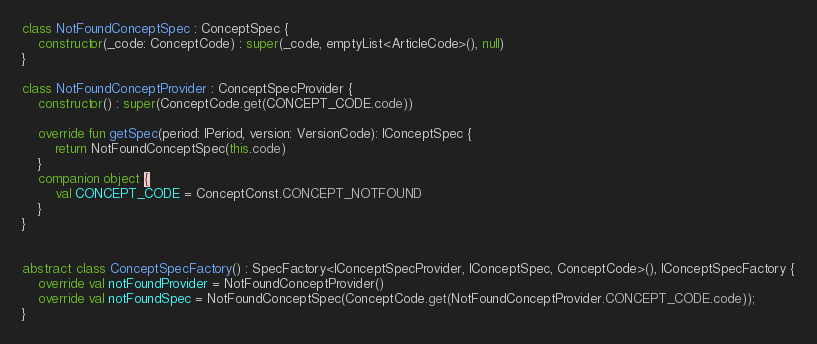<code> <loc_0><loc_0><loc_500><loc_500><_Kotlin_>class NotFoundConceptSpec : ConceptSpec {
    constructor(_code: ConceptCode) : super(_code, emptyList<ArticleCode>(), null)
}

class NotFoundConceptProvider : ConceptSpecProvider {
    constructor() : super(ConceptCode.get(CONCEPT_CODE.code))

    override fun getSpec(period: IPeriod, version: VersionCode): IConceptSpec {
        return NotFoundConceptSpec(this.code)
    }
    companion object {
        val CONCEPT_CODE = ConceptConst.CONCEPT_NOTFOUND
    }
}


abstract class ConceptSpecFactory() : SpecFactory<IConceptSpecProvider, IConceptSpec, ConceptCode>(), IConceptSpecFactory {
    override val notFoundProvider = NotFoundConceptProvider()
    override val notFoundSpec = NotFoundConceptSpec(ConceptCode.get(NotFoundConceptProvider.CONCEPT_CODE.code));
}
</code> 